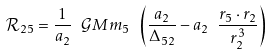Convert formula to latex. <formula><loc_0><loc_0><loc_500><loc_500>\mathcal { R } _ { 2 5 } = \frac { 1 } { a _ { 2 } } \ \mathcal { G } M m _ { 5 } \ \left ( \frac { a _ { 2 } } { \Delta _ { 5 2 } } - a _ { 2 } \ \frac { r _ { 5 } \cdot r _ { 2 } } { r _ { 2 } ^ { 3 } } \right )</formula> 